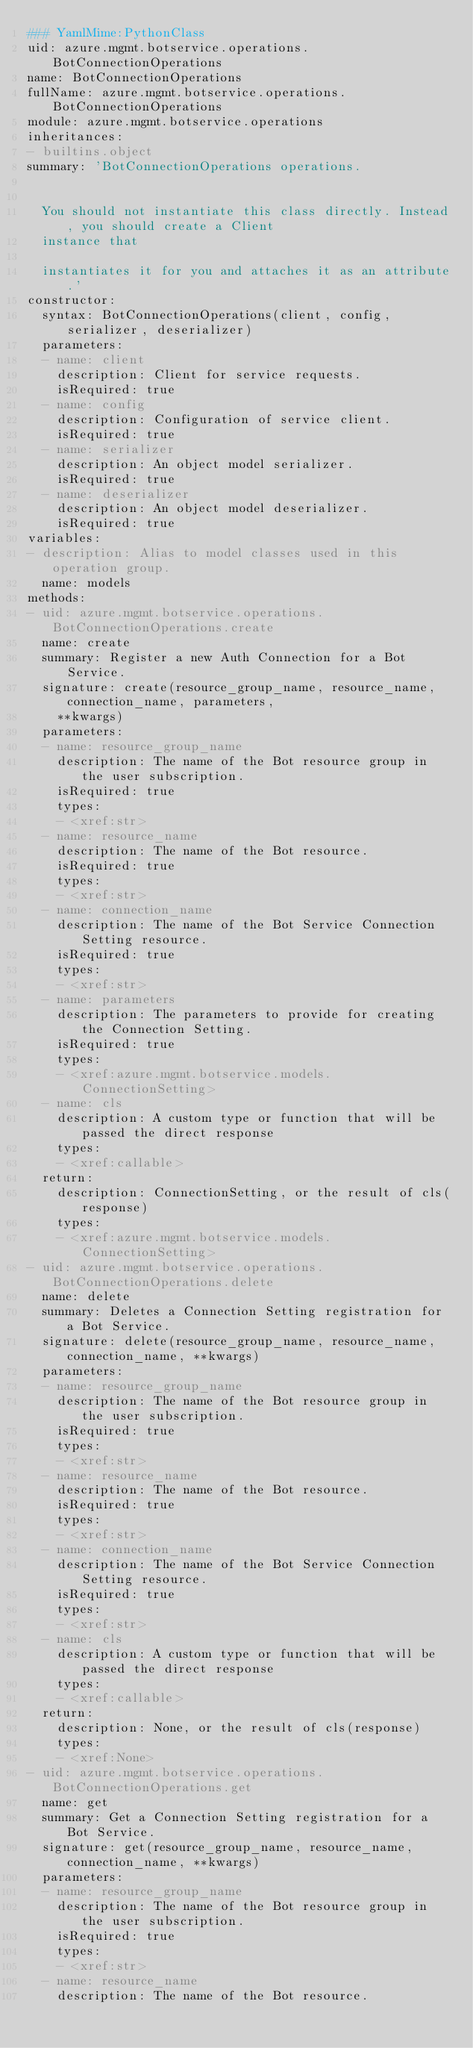Convert code to text. <code><loc_0><loc_0><loc_500><loc_500><_YAML_>### YamlMime:PythonClass
uid: azure.mgmt.botservice.operations.BotConnectionOperations
name: BotConnectionOperations
fullName: azure.mgmt.botservice.operations.BotConnectionOperations
module: azure.mgmt.botservice.operations
inheritances:
- builtins.object
summary: 'BotConnectionOperations operations.


  You should not instantiate this class directly. Instead, you should create a Client
  instance that

  instantiates it for you and attaches it as an attribute.'
constructor:
  syntax: BotConnectionOperations(client, config, serializer, deserializer)
  parameters:
  - name: client
    description: Client for service requests.
    isRequired: true
  - name: config
    description: Configuration of service client.
    isRequired: true
  - name: serializer
    description: An object model serializer.
    isRequired: true
  - name: deserializer
    description: An object model deserializer.
    isRequired: true
variables:
- description: Alias to model classes used in this operation group.
  name: models
methods:
- uid: azure.mgmt.botservice.operations.BotConnectionOperations.create
  name: create
  summary: Register a new Auth Connection for a Bot Service.
  signature: create(resource_group_name, resource_name, connection_name, parameters,
    **kwargs)
  parameters:
  - name: resource_group_name
    description: The name of the Bot resource group in the user subscription.
    isRequired: true
    types:
    - <xref:str>
  - name: resource_name
    description: The name of the Bot resource.
    isRequired: true
    types:
    - <xref:str>
  - name: connection_name
    description: The name of the Bot Service Connection Setting resource.
    isRequired: true
    types:
    - <xref:str>
  - name: parameters
    description: The parameters to provide for creating the Connection Setting.
    isRequired: true
    types:
    - <xref:azure.mgmt.botservice.models.ConnectionSetting>
  - name: cls
    description: A custom type or function that will be passed the direct response
    types:
    - <xref:callable>
  return:
    description: ConnectionSetting, or the result of cls(response)
    types:
    - <xref:azure.mgmt.botservice.models.ConnectionSetting>
- uid: azure.mgmt.botservice.operations.BotConnectionOperations.delete
  name: delete
  summary: Deletes a Connection Setting registration for a Bot Service.
  signature: delete(resource_group_name, resource_name, connection_name, **kwargs)
  parameters:
  - name: resource_group_name
    description: The name of the Bot resource group in the user subscription.
    isRequired: true
    types:
    - <xref:str>
  - name: resource_name
    description: The name of the Bot resource.
    isRequired: true
    types:
    - <xref:str>
  - name: connection_name
    description: The name of the Bot Service Connection Setting resource.
    isRequired: true
    types:
    - <xref:str>
  - name: cls
    description: A custom type or function that will be passed the direct response
    types:
    - <xref:callable>
  return:
    description: None, or the result of cls(response)
    types:
    - <xref:None>
- uid: azure.mgmt.botservice.operations.BotConnectionOperations.get
  name: get
  summary: Get a Connection Setting registration for a Bot Service.
  signature: get(resource_group_name, resource_name, connection_name, **kwargs)
  parameters:
  - name: resource_group_name
    description: The name of the Bot resource group in the user subscription.
    isRequired: true
    types:
    - <xref:str>
  - name: resource_name
    description: The name of the Bot resource.</code> 